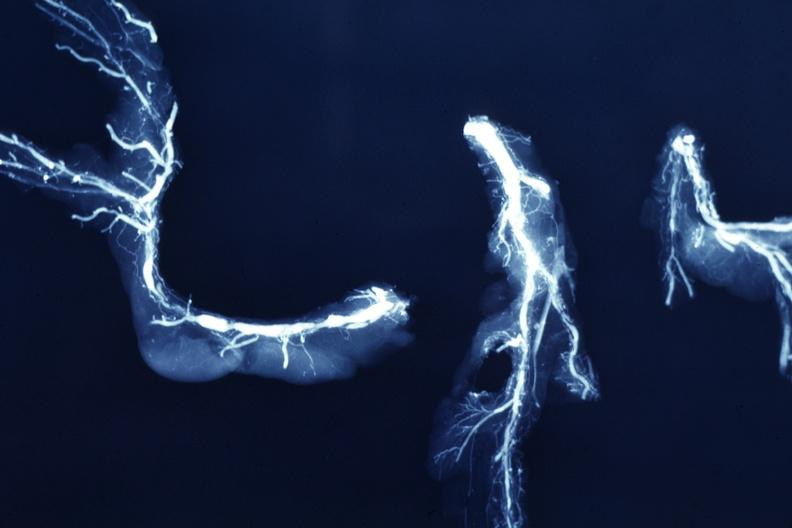what does this image show?
Answer the question using a single word or phrase. X-ray postmortdissected arteries extensive lesions 